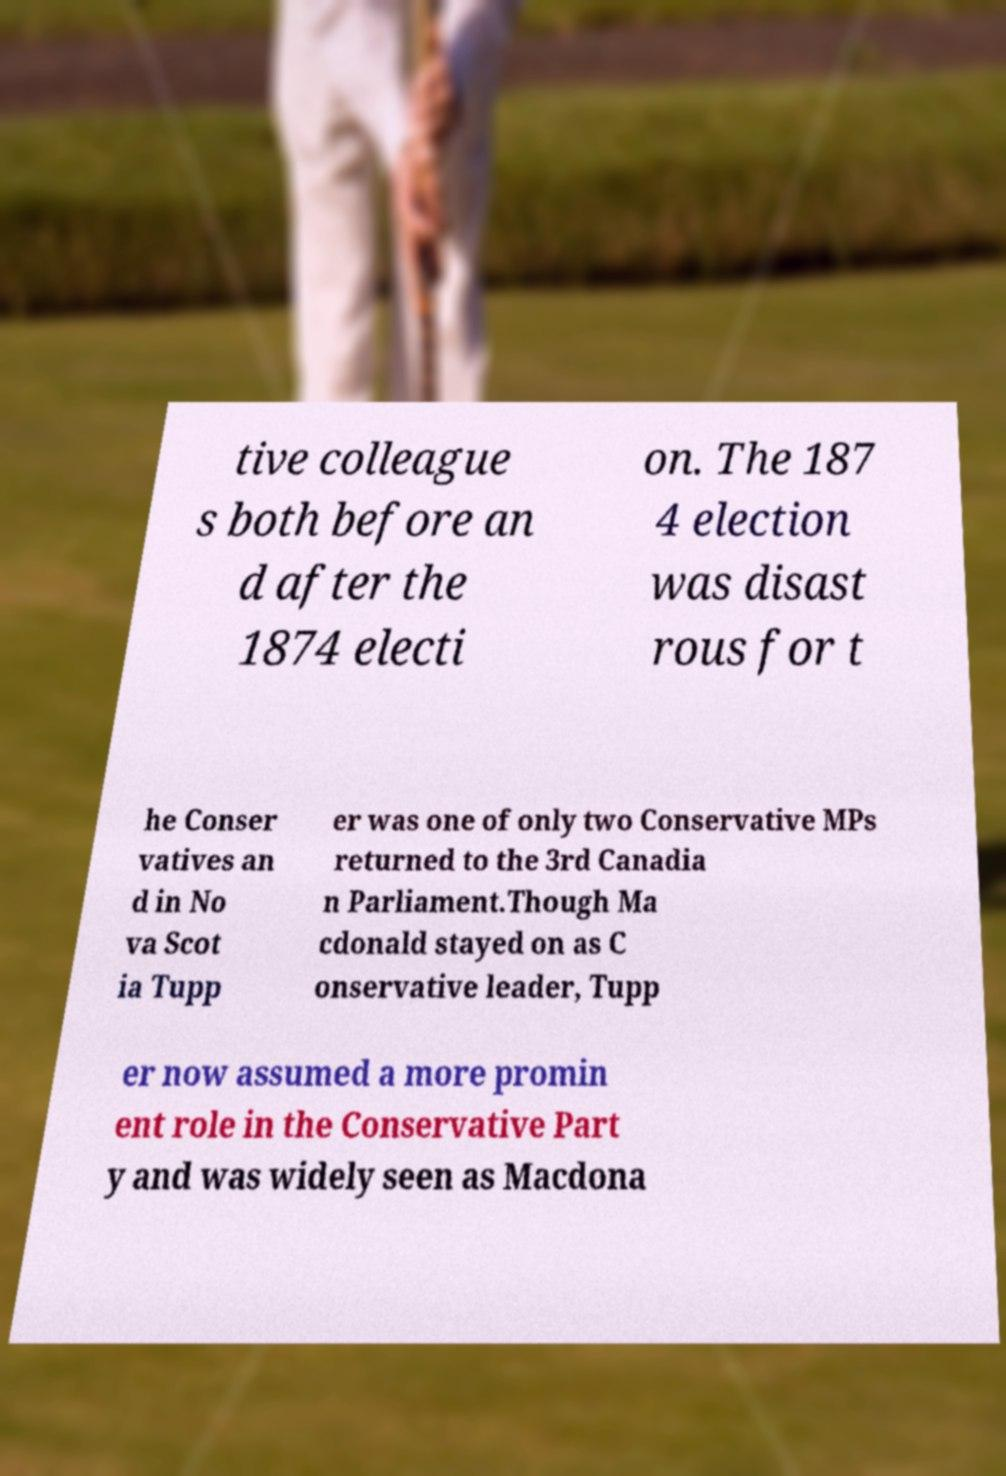There's text embedded in this image that I need extracted. Can you transcribe it verbatim? tive colleague s both before an d after the 1874 electi on. The 187 4 election was disast rous for t he Conser vatives an d in No va Scot ia Tupp er was one of only two Conservative MPs returned to the 3rd Canadia n Parliament.Though Ma cdonald stayed on as C onservative leader, Tupp er now assumed a more promin ent role in the Conservative Part y and was widely seen as Macdona 